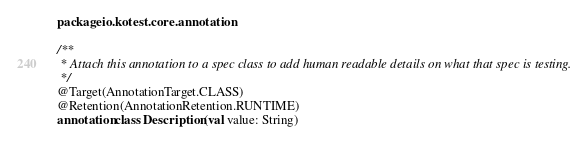Convert code to text. <code><loc_0><loc_0><loc_500><loc_500><_Kotlin_>package io.kotest.core.annotation

/**
 * Attach this annotation to a spec class to add human readable details on what that spec is testing.
 */
@Target(AnnotationTarget.CLASS)
@Retention(AnnotationRetention.RUNTIME)
annotation class Description(val value: String)
</code> 